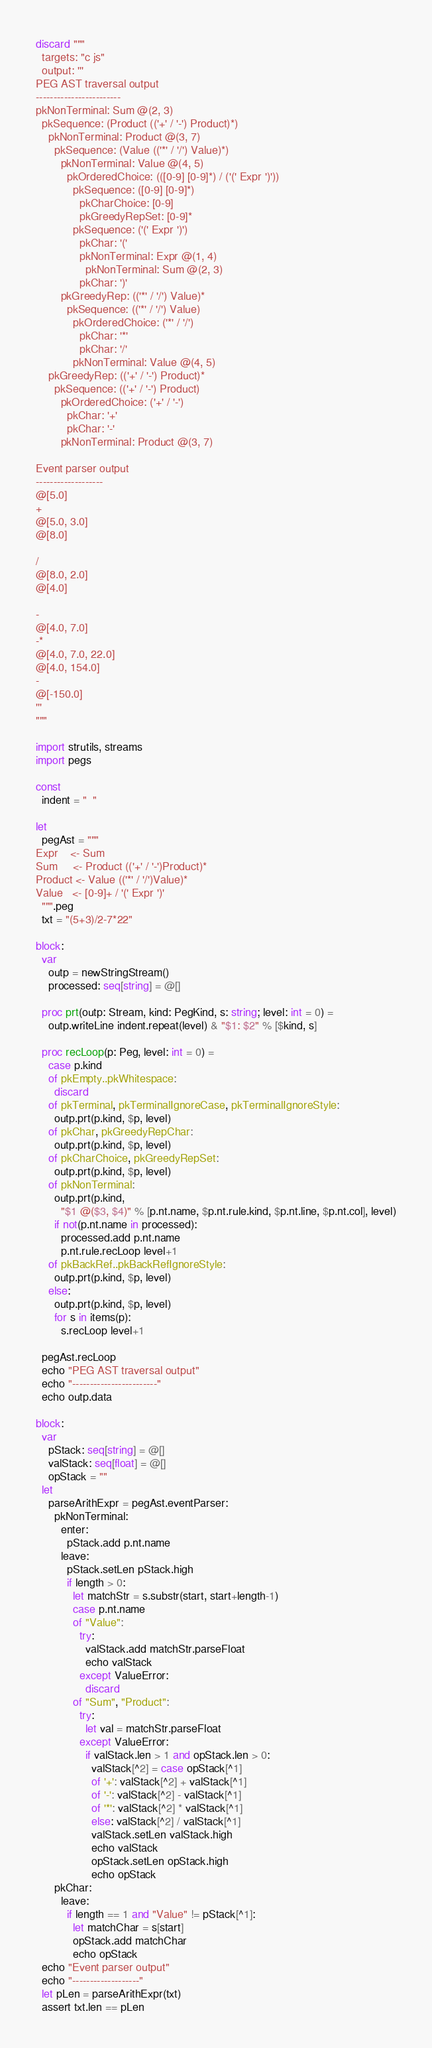Convert code to text. <code><loc_0><loc_0><loc_500><loc_500><_Nim_>discard """
  targets: "c js"
  output: '''
PEG AST traversal output
------------------------
pkNonTerminal: Sum @(2, 3)
  pkSequence: (Product (('+' / '-') Product)*)
    pkNonTerminal: Product @(3, 7)
      pkSequence: (Value (('*' / '/') Value)*)
        pkNonTerminal: Value @(4, 5)
          pkOrderedChoice: (([0-9] [0-9]*) / ('(' Expr ')'))
            pkSequence: ([0-9] [0-9]*)
              pkCharChoice: [0-9]
              pkGreedyRepSet: [0-9]*
            pkSequence: ('(' Expr ')')
              pkChar: '('
              pkNonTerminal: Expr @(1, 4)
                pkNonTerminal: Sum @(2, 3)
              pkChar: ')'
        pkGreedyRep: (('*' / '/') Value)*
          pkSequence: (('*' / '/') Value)
            pkOrderedChoice: ('*' / '/')
              pkChar: '*'
              pkChar: '/'
            pkNonTerminal: Value @(4, 5)
    pkGreedyRep: (('+' / '-') Product)*
      pkSequence: (('+' / '-') Product)
        pkOrderedChoice: ('+' / '-')
          pkChar: '+'
          pkChar: '-'
        pkNonTerminal: Product @(3, 7)

Event parser output
-------------------
@[5.0]
+
@[5.0, 3.0]
@[8.0]

/
@[8.0, 2.0]
@[4.0]

-
@[4.0, 7.0]
-*
@[4.0, 7.0, 22.0]
@[4.0, 154.0]
-
@[-150.0]
'''
"""

import strutils, streams
import pegs

const
  indent = "  "

let
  pegAst = """
Expr    <- Sum
Sum     <- Product (('+' / '-')Product)*
Product <- Value (('*' / '/')Value)*
Value   <- [0-9]+ / '(' Expr ')'
  """.peg
  txt = "(5+3)/2-7*22"

block:
  var
    outp = newStringStream()
    processed: seq[string] = @[]

  proc prt(outp: Stream, kind: PegKind, s: string; level: int = 0) =
    outp.writeLine indent.repeat(level) & "$1: $2" % [$kind, s]

  proc recLoop(p: Peg, level: int = 0) =
    case p.kind
    of pkEmpty..pkWhitespace:
      discard
    of pkTerminal, pkTerminalIgnoreCase, pkTerminalIgnoreStyle:
      outp.prt(p.kind, $p, level)
    of pkChar, pkGreedyRepChar:
      outp.prt(p.kind, $p, level)
    of pkCharChoice, pkGreedyRepSet:
      outp.prt(p.kind, $p, level)
    of pkNonTerminal:
      outp.prt(p.kind,
        "$1 @($3, $4)" % [p.nt.name, $p.nt.rule.kind, $p.nt.line, $p.nt.col], level)
      if not(p.nt.name in processed):
        processed.add p.nt.name
        p.nt.rule.recLoop level+1
    of pkBackRef..pkBackRefIgnoreStyle:
      outp.prt(p.kind, $p, level)
    else:
      outp.prt(p.kind, $p, level)
      for s in items(p):
        s.recLoop level+1

  pegAst.recLoop
  echo "PEG AST traversal output"
  echo "------------------------"
  echo outp.data

block:
  var
    pStack: seq[string] = @[]
    valStack: seq[float] = @[]
    opStack = ""
  let
    parseArithExpr = pegAst.eventParser:
      pkNonTerminal:
        enter:
          pStack.add p.nt.name
        leave:
          pStack.setLen pStack.high
          if length > 0:
            let matchStr = s.substr(start, start+length-1)
            case p.nt.name
            of "Value":
              try:
                valStack.add matchStr.parseFloat
                echo valStack
              except ValueError:
                discard
            of "Sum", "Product":
              try:
                let val = matchStr.parseFloat
              except ValueError:
                if valStack.len > 1 and opStack.len > 0:
                  valStack[^2] = case opStack[^1]
                  of '+': valStack[^2] + valStack[^1]
                  of '-': valStack[^2] - valStack[^1]
                  of '*': valStack[^2] * valStack[^1]
                  else: valStack[^2] / valStack[^1]
                  valStack.setLen valStack.high
                  echo valStack
                  opStack.setLen opStack.high
                  echo opStack
      pkChar:
        leave:
          if length == 1 and "Value" != pStack[^1]:
            let matchChar = s[start]
            opStack.add matchChar
            echo opStack
  echo "Event parser output"
  echo "-------------------"
  let pLen = parseArithExpr(txt)
  assert txt.len == pLen
</code> 